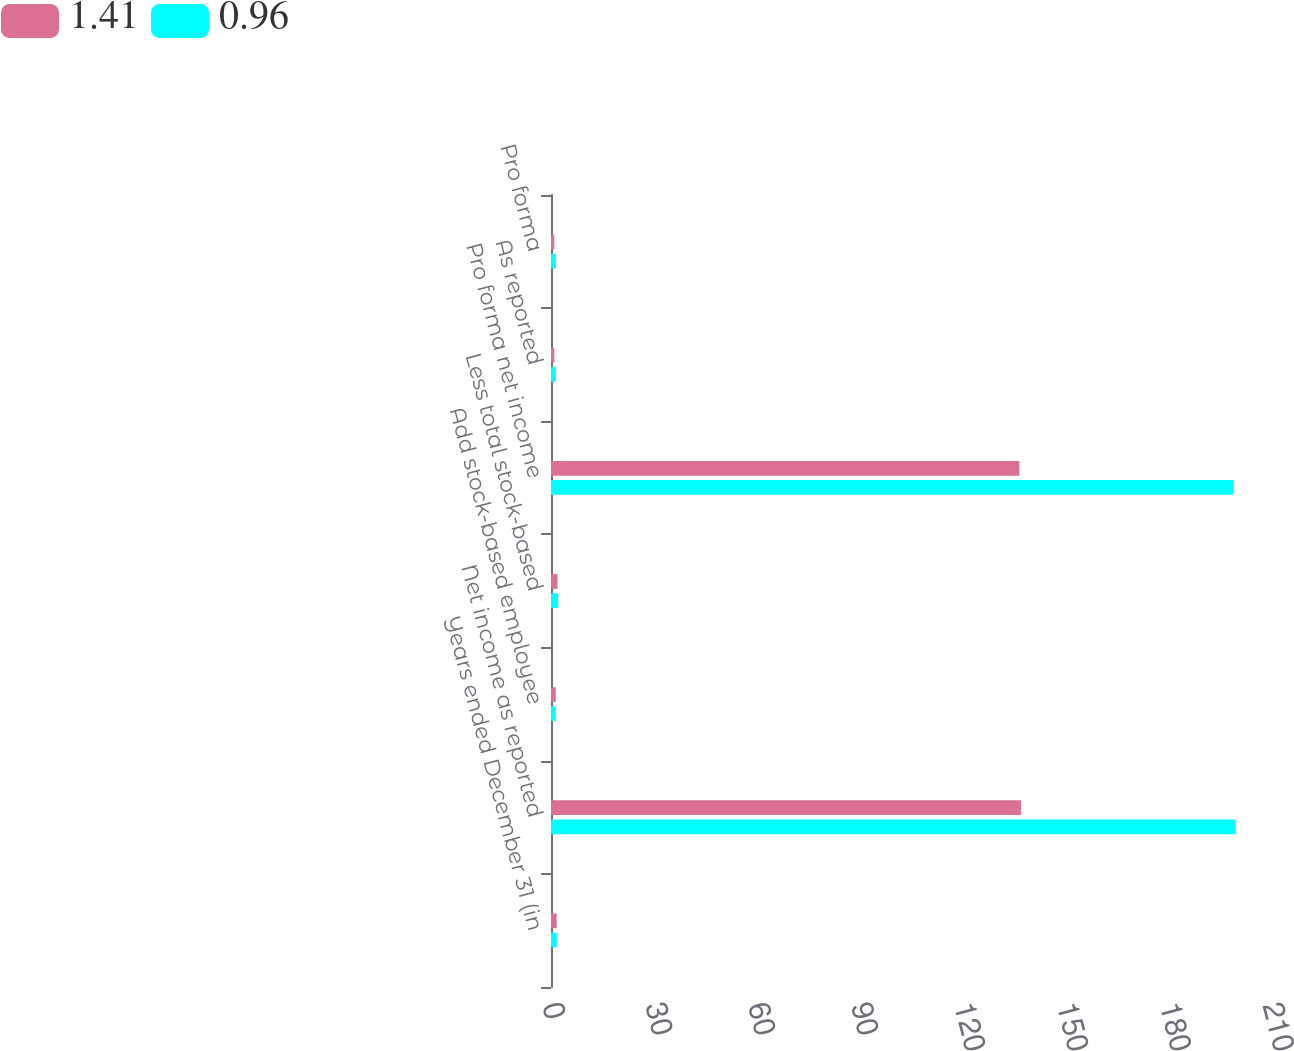<chart> <loc_0><loc_0><loc_500><loc_500><stacked_bar_chart><ecel><fcel>Years ended December 31 (in<fcel>Net income as reported<fcel>Add stock-based employee<fcel>Less total stock-based<fcel>Pro forma net income<fcel>As reported<fcel>Pro forma<nl><fcel>1.41<fcel>1.665<fcel>137.1<fcel>1.4<fcel>1.9<fcel>136.6<fcel>0.97<fcel>0.97<nl><fcel>0.96<fcel>1.665<fcel>199.7<fcel>1.4<fcel>2.1<fcel>199<fcel>1.43<fcel>1.42<nl></chart> 